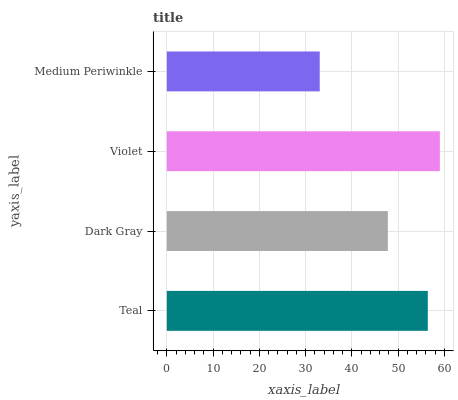Is Medium Periwinkle the minimum?
Answer yes or no. Yes. Is Violet the maximum?
Answer yes or no. Yes. Is Dark Gray the minimum?
Answer yes or no. No. Is Dark Gray the maximum?
Answer yes or no. No. Is Teal greater than Dark Gray?
Answer yes or no. Yes. Is Dark Gray less than Teal?
Answer yes or no. Yes. Is Dark Gray greater than Teal?
Answer yes or no. No. Is Teal less than Dark Gray?
Answer yes or no. No. Is Teal the high median?
Answer yes or no. Yes. Is Dark Gray the low median?
Answer yes or no. Yes. Is Dark Gray the high median?
Answer yes or no. No. Is Teal the low median?
Answer yes or no. No. 